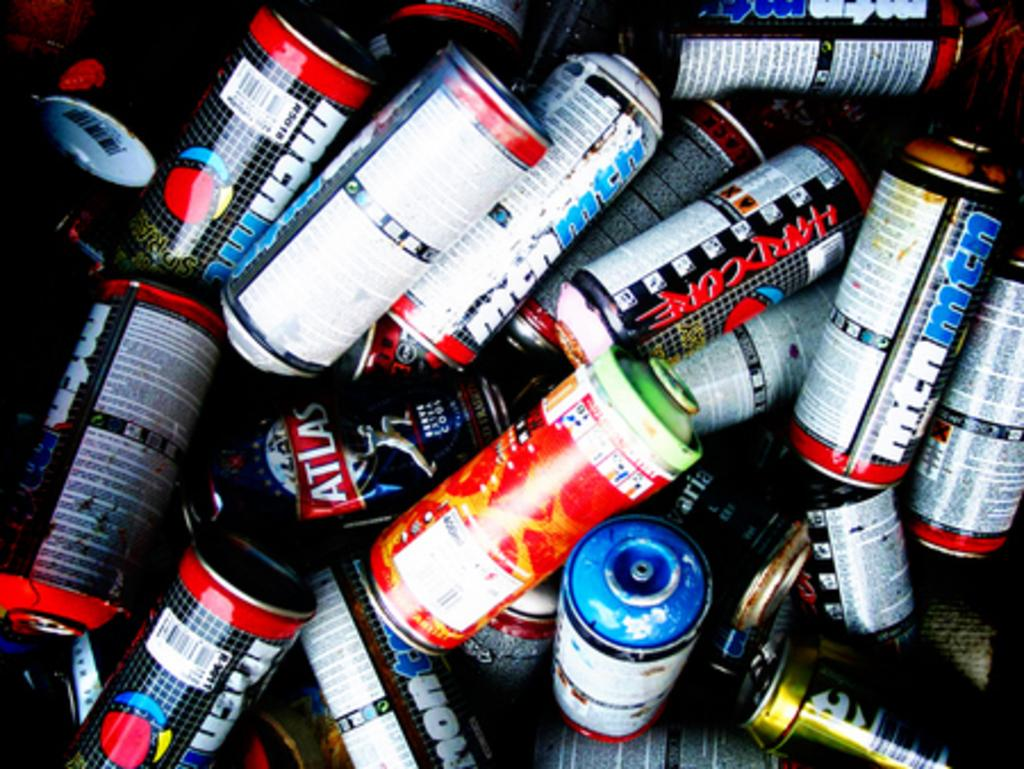<image>
Write a terse but informative summary of the picture. Many cans including one with the word HARDCORE down its side are in a pile. 